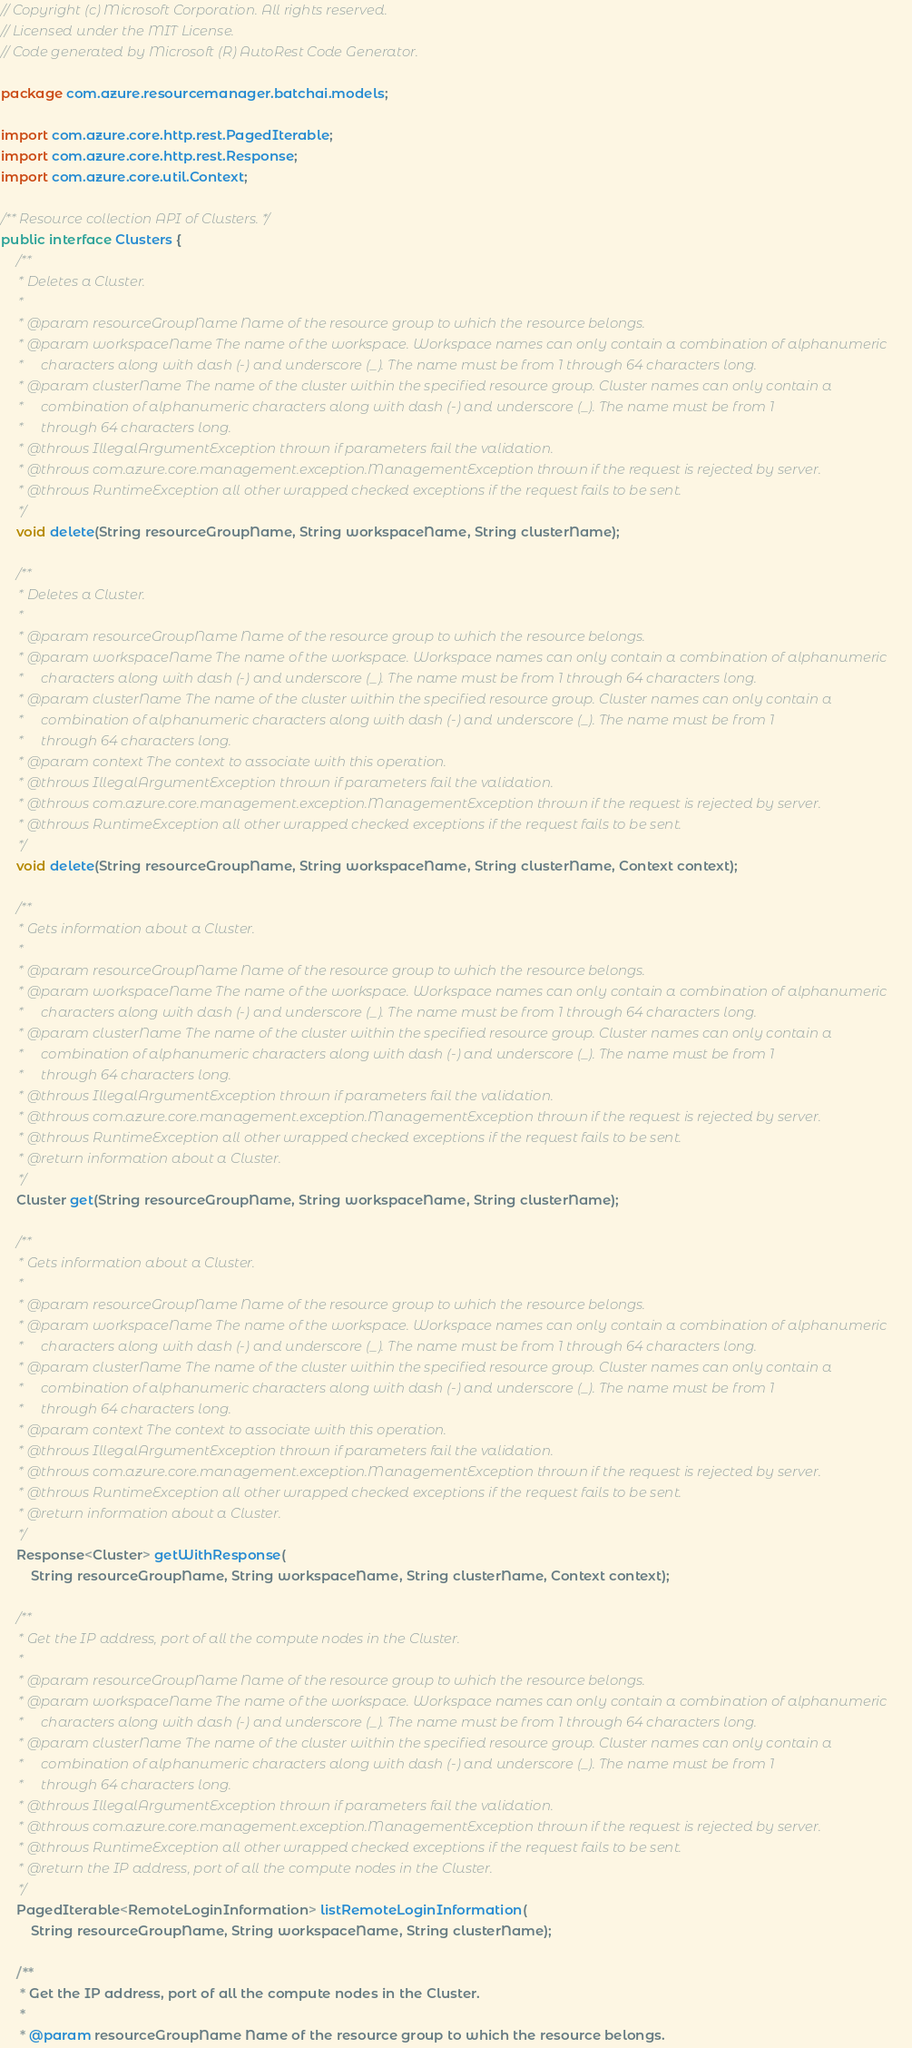<code> <loc_0><loc_0><loc_500><loc_500><_Java_>// Copyright (c) Microsoft Corporation. All rights reserved.
// Licensed under the MIT License.
// Code generated by Microsoft (R) AutoRest Code Generator.

package com.azure.resourcemanager.batchai.models;

import com.azure.core.http.rest.PagedIterable;
import com.azure.core.http.rest.Response;
import com.azure.core.util.Context;

/** Resource collection API of Clusters. */
public interface Clusters {
    /**
     * Deletes a Cluster.
     *
     * @param resourceGroupName Name of the resource group to which the resource belongs.
     * @param workspaceName The name of the workspace. Workspace names can only contain a combination of alphanumeric
     *     characters along with dash (-) and underscore (_). The name must be from 1 through 64 characters long.
     * @param clusterName The name of the cluster within the specified resource group. Cluster names can only contain a
     *     combination of alphanumeric characters along with dash (-) and underscore (_). The name must be from 1
     *     through 64 characters long.
     * @throws IllegalArgumentException thrown if parameters fail the validation.
     * @throws com.azure.core.management.exception.ManagementException thrown if the request is rejected by server.
     * @throws RuntimeException all other wrapped checked exceptions if the request fails to be sent.
     */
    void delete(String resourceGroupName, String workspaceName, String clusterName);

    /**
     * Deletes a Cluster.
     *
     * @param resourceGroupName Name of the resource group to which the resource belongs.
     * @param workspaceName The name of the workspace. Workspace names can only contain a combination of alphanumeric
     *     characters along with dash (-) and underscore (_). The name must be from 1 through 64 characters long.
     * @param clusterName The name of the cluster within the specified resource group. Cluster names can only contain a
     *     combination of alphanumeric characters along with dash (-) and underscore (_). The name must be from 1
     *     through 64 characters long.
     * @param context The context to associate with this operation.
     * @throws IllegalArgumentException thrown if parameters fail the validation.
     * @throws com.azure.core.management.exception.ManagementException thrown if the request is rejected by server.
     * @throws RuntimeException all other wrapped checked exceptions if the request fails to be sent.
     */
    void delete(String resourceGroupName, String workspaceName, String clusterName, Context context);

    /**
     * Gets information about a Cluster.
     *
     * @param resourceGroupName Name of the resource group to which the resource belongs.
     * @param workspaceName The name of the workspace. Workspace names can only contain a combination of alphanumeric
     *     characters along with dash (-) and underscore (_). The name must be from 1 through 64 characters long.
     * @param clusterName The name of the cluster within the specified resource group. Cluster names can only contain a
     *     combination of alphanumeric characters along with dash (-) and underscore (_). The name must be from 1
     *     through 64 characters long.
     * @throws IllegalArgumentException thrown if parameters fail the validation.
     * @throws com.azure.core.management.exception.ManagementException thrown if the request is rejected by server.
     * @throws RuntimeException all other wrapped checked exceptions if the request fails to be sent.
     * @return information about a Cluster.
     */
    Cluster get(String resourceGroupName, String workspaceName, String clusterName);

    /**
     * Gets information about a Cluster.
     *
     * @param resourceGroupName Name of the resource group to which the resource belongs.
     * @param workspaceName The name of the workspace. Workspace names can only contain a combination of alphanumeric
     *     characters along with dash (-) and underscore (_). The name must be from 1 through 64 characters long.
     * @param clusterName The name of the cluster within the specified resource group. Cluster names can only contain a
     *     combination of alphanumeric characters along with dash (-) and underscore (_). The name must be from 1
     *     through 64 characters long.
     * @param context The context to associate with this operation.
     * @throws IllegalArgumentException thrown if parameters fail the validation.
     * @throws com.azure.core.management.exception.ManagementException thrown if the request is rejected by server.
     * @throws RuntimeException all other wrapped checked exceptions if the request fails to be sent.
     * @return information about a Cluster.
     */
    Response<Cluster> getWithResponse(
        String resourceGroupName, String workspaceName, String clusterName, Context context);

    /**
     * Get the IP address, port of all the compute nodes in the Cluster.
     *
     * @param resourceGroupName Name of the resource group to which the resource belongs.
     * @param workspaceName The name of the workspace. Workspace names can only contain a combination of alphanumeric
     *     characters along with dash (-) and underscore (_). The name must be from 1 through 64 characters long.
     * @param clusterName The name of the cluster within the specified resource group. Cluster names can only contain a
     *     combination of alphanumeric characters along with dash (-) and underscore (_). The name must be from 1
     *     through 64 characters long.
     * @throws IllegalArgumentException thrown if parameters fail the validation.
     * @throws com.azure.core.management.exception.ManagementException thrown if the request is rejected by server.
     * @throws RuntimeException all other wrapped checked exceptions if the request fails to be sent.
     * @return the IP address, port of all the compute nodes in the Cluster.
     */
    PagedIterable<RemoteLoginInformation> listRemoteLoginInformation(
        String resourceGroupName, String workspaceName, String clusterName);

    /**
     * Get the IP address, port of all the compute nodes in the Cluster.
     *
     * @param resourceGroupName Name of the resource group to which the resource belongs.</code> 